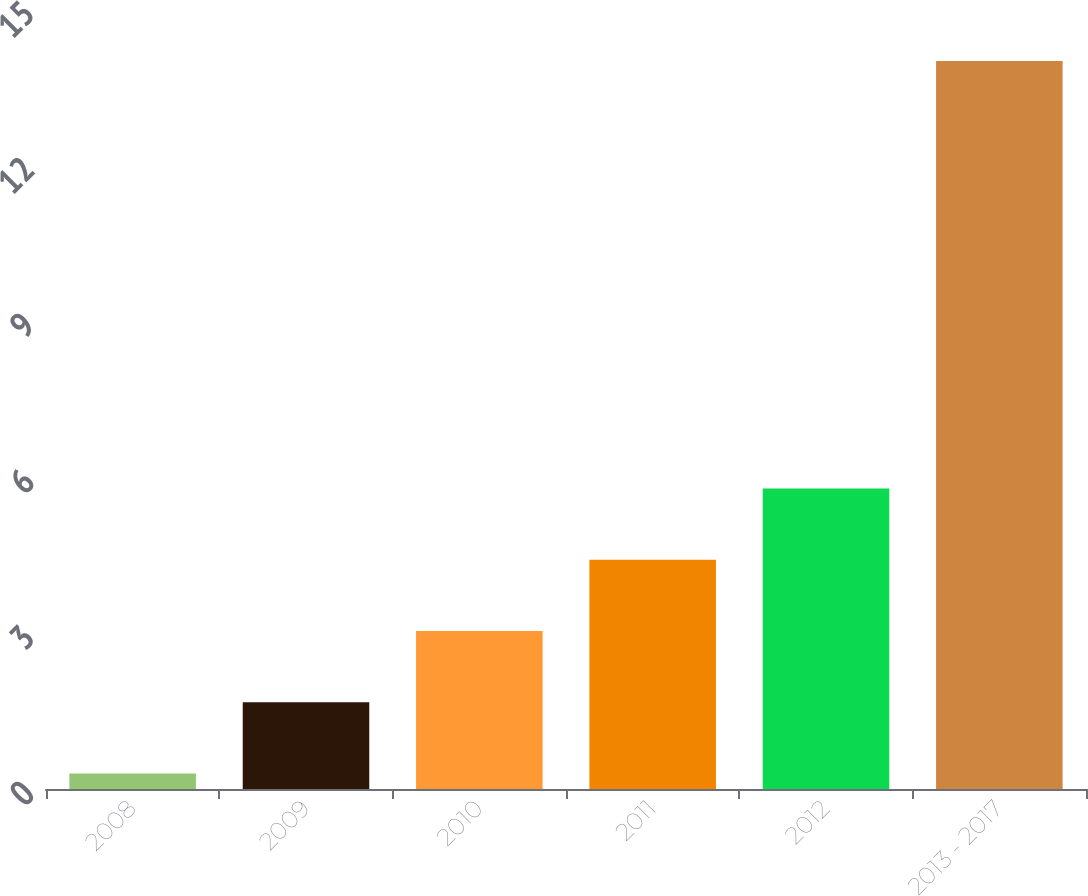Convert chart to OTSL. <chart><loc_0><loc_0><loc_500><loc_500><bar_chart><fcel>2008<fcel>2009<fcel>2010<fcel>2011<fcel>2012<fcel>2013 - 2017<nl><fcel>0.3<fcel>1.67<fcel>3.04<fcel>4.41<fcel>5.78<fcel>14<nl></chart> 